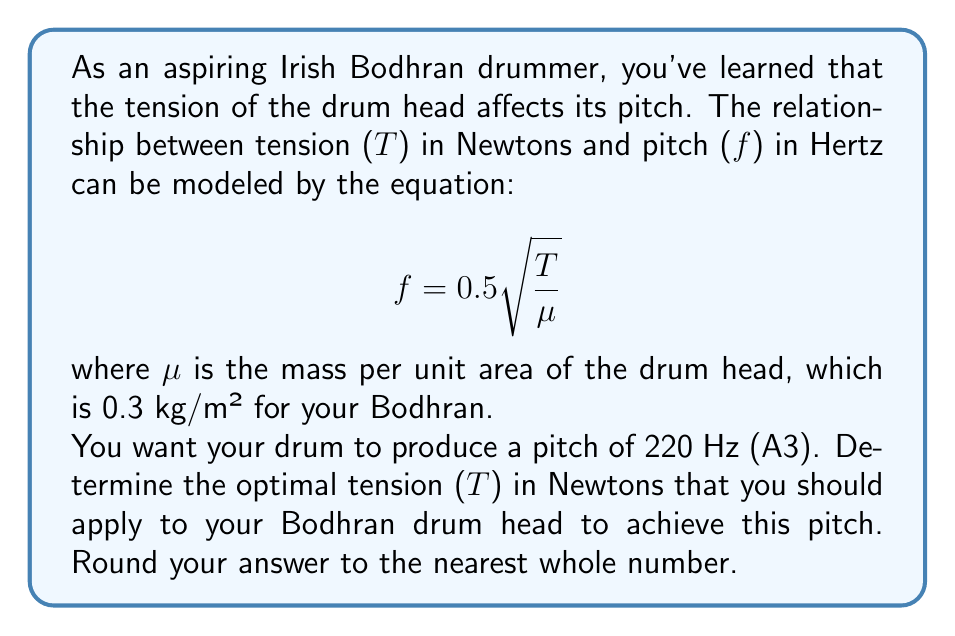Help me with this question. Let's approach this step-by-step:

1) We start with the given equation:
   $$ f = 0.5 \sqrt{\frac{T}{\mu}} $$

2) We know the following:
   - $f = 220$ Hz (desired pitch)
   - $\mu = 0.3$ kg/m² (mass per unit area of the drum head)

3) Let's substitute these values into the equation:
   $$ 220 = 0.5 \sqrt{\frac{T}{0.3}} $$

4) To solve for T, let's first square both sides:
   $$ 220^2 = (0.5)^2 \cdot \frac{T}{0.3} $$

5) Simplify:
   $$ 48400 = 0.25 \cdot \frac{T}{0.3} $$

6) Multiply both sides by 0.3:
   $$ 48400 \cdot 0.3 = 0.25T $$

7) Simplify:
   $$ 14520 = 0.25T $$

8) Divide both sides by 0.25:
   $$ \frac{14520}{0.25} = T $$

9) Calculate:
   $$ T = 58080 \text{ N} $$

10) Rounding to the nearest whole number:
    $$ T \approx 58080 \text{ N} $$
Answer: The optimal tension for the Bodhran drum head to produce a pitch of 220 Hz is approximately 58080 N. 